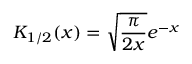<formula> <loc_0><loc_0><loc_500><loc_500>K _ { 1 / 2 } ( x ) = \sqrt { \frac { \pi } { 2 x } } e ^ { - x }</formula> 